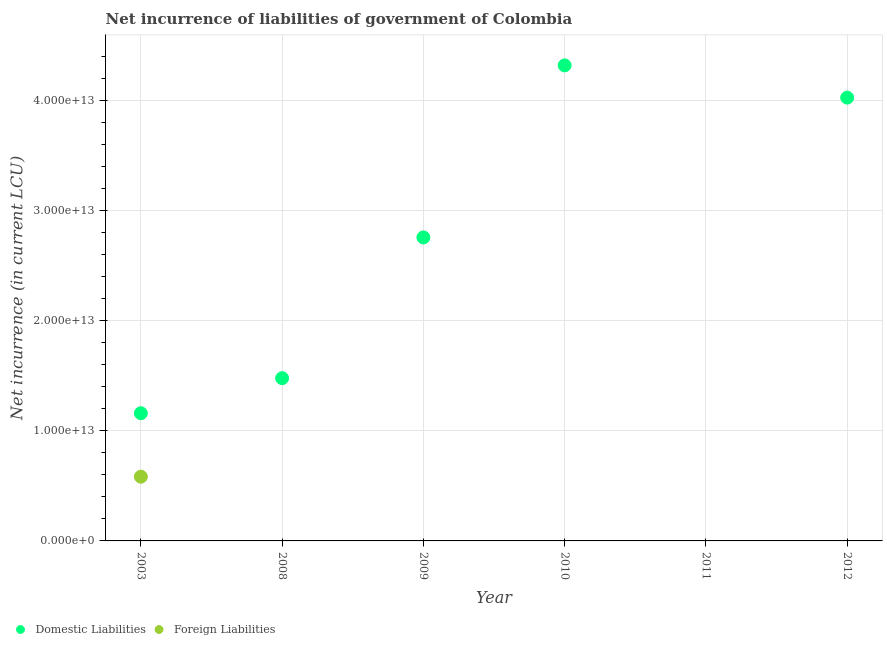What is the net incurrence of foreign liabilities in 2003?
Your answer should be very brief. 5.83e+12. Across all years, what is the maximum net incurrence of domestic liabilities?
Offer a terse response. 4.32e+13. Across all years, what is the minimum net incurrence of foreign liabilities?
Ensure brevity in your answer.  0. What is the total net incurrence of domestic liabilities in the graph?
Your response must be concise. 1.37e+14. What is the difference between the net incurrence of domestic liabilities in 2008 and that in 2012?
Make the answer very short. -2.55e+13. What is the difference between the net incurrence of foreign liabilities in 2010 and the net incurrence of domestic liabilities in 2012?
Your answer should be compact. -4.03e+13. What is the average net incurrence of domestic liabilities per year?
Give a very brief answer. 2.29e+13. In how many years, is the net incurrence of foreign liabilities greater than 8000000000000 LCU?
Give a very brief answer. 0. What is the ratio of the net incurrence of domestic liabilities in 2003 to that in 2008?
Make the answer very short. 0.78. What is the difference between the highest and the second highest net incurrence of domestic liabilities?
Your answer should be very brief. 2.93e+12. What is the difference between the highest and the lowest net incurrence of foreign liabilities?
Your response must be concise. 5.83e+12. Does the net incurrence of domestic liabilities monotonically increase over the years?
Give a very brief answer. No. How many dotlines are there?
Your answer should be compact. 2. What is the difference between two consecutive major ticks on the Y-axis?
Your response must be concise. 1.00e+13. What is the title of the graph?
Keep it short and to the point. Net incurrence of liabilities of government of Colombia. What is the label or title of the X-axis?
Give a very brief answer. Year. What is the label or title of the Y-axis?
Offer a terse response. Net incurrence (in current LCU). What is the Net incurrence (in current LCU) of Domestic Liabilities in 2003?
Ensure brevity in your answer.  1.16e+13. What is the Net incurrence (in current LCU) of Foreign Liabilities in 2003?
Your response must be concise. 5.83e+12. What is the Net incurrence (in current LCU) in Domestic Liabilities in 2008?
Your answer should be compact. 1.48e+13. What is the Net incurrence (in current LCU) of Domestic Liabilities in 2009?
Offer a terse response. 2.76e+13. What is the Net incurrence (in current LCU) in Foreign Liabilities in 2009?
Offer a terse response. 0. What is the Net incurrence (in current LCU) in Domestic Liabilities in 2010?
Provide a succinct answer. 4.32e+13. What is the Net incurrence (in current LCU) in Domestic Liabilities in 2011?
Offer a terse response. 0. What is the Net incurrence (in current LCU) of Foreign Liabilities in 2011?
Offer a terse response. 0. What is the Net incurrence (in current LCU) in Domestic Liabilities in 2012?
Your response must be concise. 4.03e+13. Across all years, what is the maximum Net incurrence (in current LCU) in Domestic Liabilities?
Offer a terse response. 4.32e+13. Across all years, what is the maximum Net incurrence (in current LCU) of Foreign Liabilities?
Offer a very short reply. 5.83e+12. Across all years, what is the minimum Net incurrence (in current LCU) of Foreign Liabilities?
Offer a very short reply. 0. What is the total Net incurrence (in current LCU) of Domestic Liabilities in the graph?
Your response must be concise. 1.37e+14. What is the total Net incurrence (in current LCU) in Foreign Liabilities in the graph?
Your response must be concise. 5.83e+12. What is the difference between the Net incurrence (in current LCU) in Domestic Liabilities in 2003 and that in 2008?
Provide a succinct answer. -3.18e+12. What is the difference between the Net incurrence (in current LCU) in Domestic Liabilities in 2003 and that in 2009?
Provide a succinct answer. -1.60e+13. What is the difference between the Net incurrence (in current LCU) of Domestic Liabilities in 2003 and that in 2010?
Keep it short and to the point. -3.16e+13. What is the difference between the Net incurrence (in current LCU) in Domestic Liabilities in 2003 and that in 2012?
Keep it short and to the point. -2.87e+13. What is the difference between the Net incurrence (in current LCU) of Domestic Liabilities in 2008 and that in 2009?
Offer a very short reply. -1.28e+13. What is the difference between the Net incurrence (in current LCU) of Domestic Liabilities in 2008 and that in 2010?
Make the answer very short. -2.84e+13. What is the difference between the Net incurrence (in current LCU) of Domestic Liabilities in 2008 and that in 2012?
Give a very brief answer. -2.55e+13. What is the difference between the Net incurrence (in current LCU) in Domestic Liabilities in 2009 and that in 2010?
Keep it short and to the point. -1.56e+13. What is the difference between the Net incurrence (in current LCU) of Domestic Liabilities in 2009 and that in 2012?
Your answer should be compact. -1.27e+13. What is the difference between the Net incurrence (in current LCU) of Domestic Liabilities in 2010 and that in 2012?
Ensure brevity in your answer.  2.93e+12. What is the average Net incurrence (in current LCU) in Domestic Liabilities per year?
Ensure brevity in your answer.  2.29e+13. What is the average Net incurrence (in current LCU) of Foreign Liabilities per year?
Your response must be concise. 9.72e+11. In the year 2003, what is the difference between the Net incurrence (in current LCU) in Domestic Liabilities and Net incurrence (in current LCU) in Foreign Liabilities?
Keep it short and to the point. 5.76e+12. What is the ratio of the Net incurrence (in current LCU) of Domestic Liabilities in 2003 to that in 2008?
Offer a terse response. 0.78. What is the ratio of the Net incurrence (in current LCU) in Domestic Liabilities in 2003 to that in 2009?
Ensure brevity in your answer.  0.42. What is the ratio of the Net incurrence (in current LCU) in Domestic Liabilities in 2003 to that in 2010?
Give a very brief answer. 0.27. What is the ratio of the Net incurrence (in current LCU) of Domestic Liabilities in 2003 to that in 2012?
Keep it short and to the point. 0.29. What is the ratio of the Net incurrence (in current LCU) in Domestic Liabilities in 2008 to that in 2009?
Keep it short and to the point. 0.54. What is the ratio of the Net incurrence (in current LCU) of Domestic Liabilities in 2008 to that in 2010?
Offer a very short reply. 0.34. What is the ratio of the Net incurrence (in current LCU) in Domestic Liabilities in 2008 to that in 2012?
Offer a terse response. 0.37. What is the ratio of the Net incurrence (in current LCU) of Domestic Liabilities in 2009 to that in 2010?
Ensure brevity in your answer.  0.64. What is the ratio of the Net incurrence (in current LCU) of Domestic Liabilities in 2009 to that in 2012?
Provide a short and direct response. 0.68. What is the ratio of the Net incurrence (in current LCU) of Domestic Liabilities in 2010 to that in 2012?
Offer a terse response. 1.07. What is the difference between the highest and the second highest Net incurrence (in current LCU) in Domestic Liabilities?
Offer a terse response. 2.93e+12. What is the difference between the highest and the lowest Net incurrence (in current LCU) of Domestic Liabilities?
Your answer should be very brief. 4.32e+13. What is the difference between the highest and the lowest Net incurrence (in current LCU) of Foreign Liabilities?
Ensure brevity in your answer.  5.83e+12. 